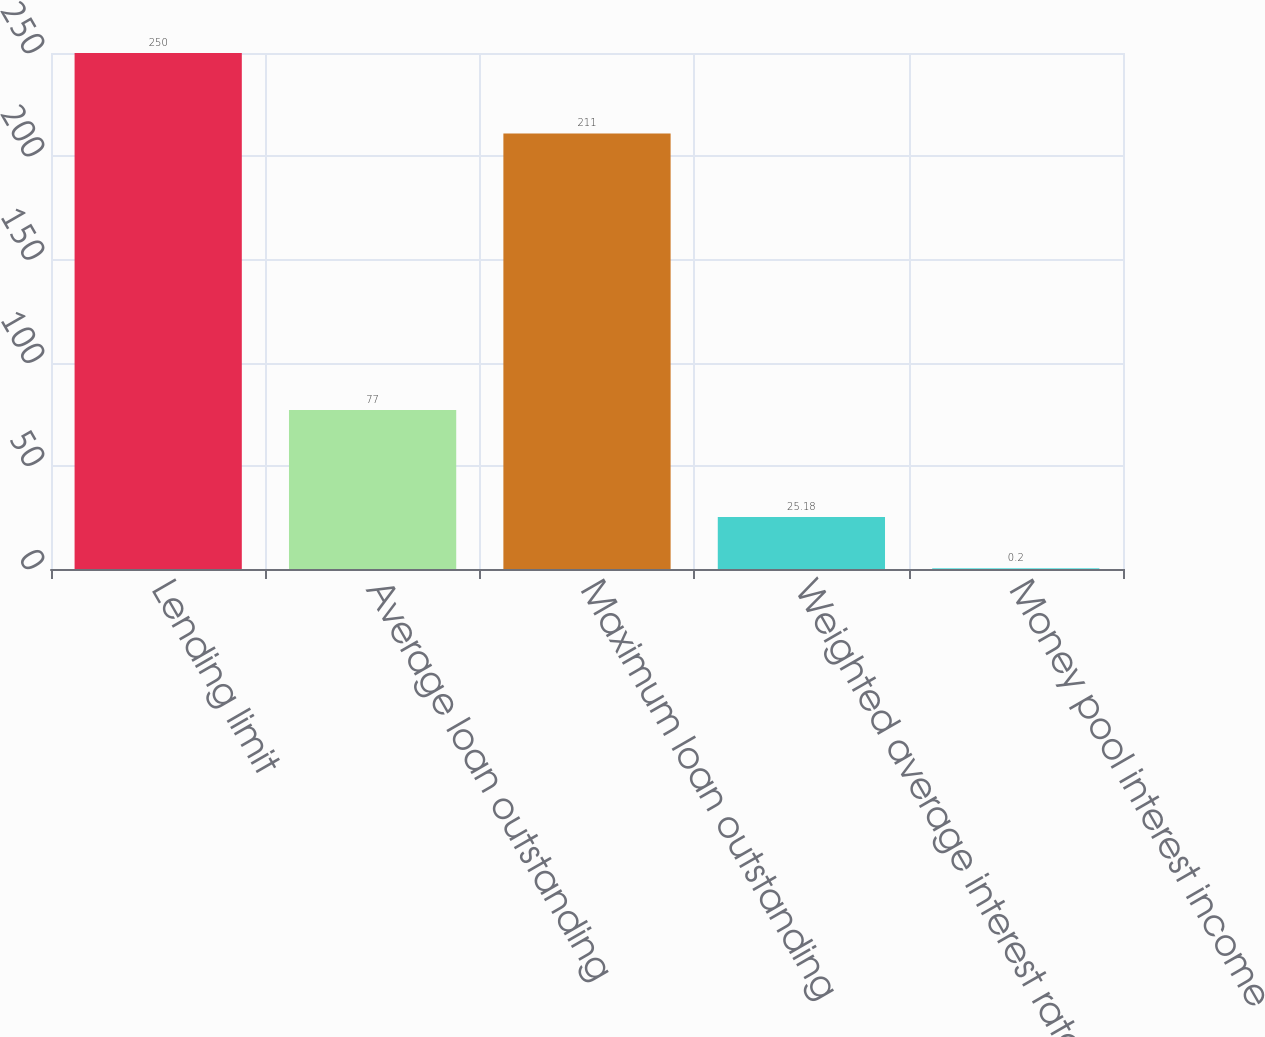Convert chart to OTSL. <chart><loc_0><loc_0><loc_500><loc_500><bar_chart><fcel>Lending limit<fcel>Average loan outstanding<fcel>Maximum loan outstanding<fcel>Weighted average interest rate<fcel>Money pool interest income<nl><fcel>250<fcel>77<fcel>211<fcel>25.18<fcel>0.2<nl></chart> 